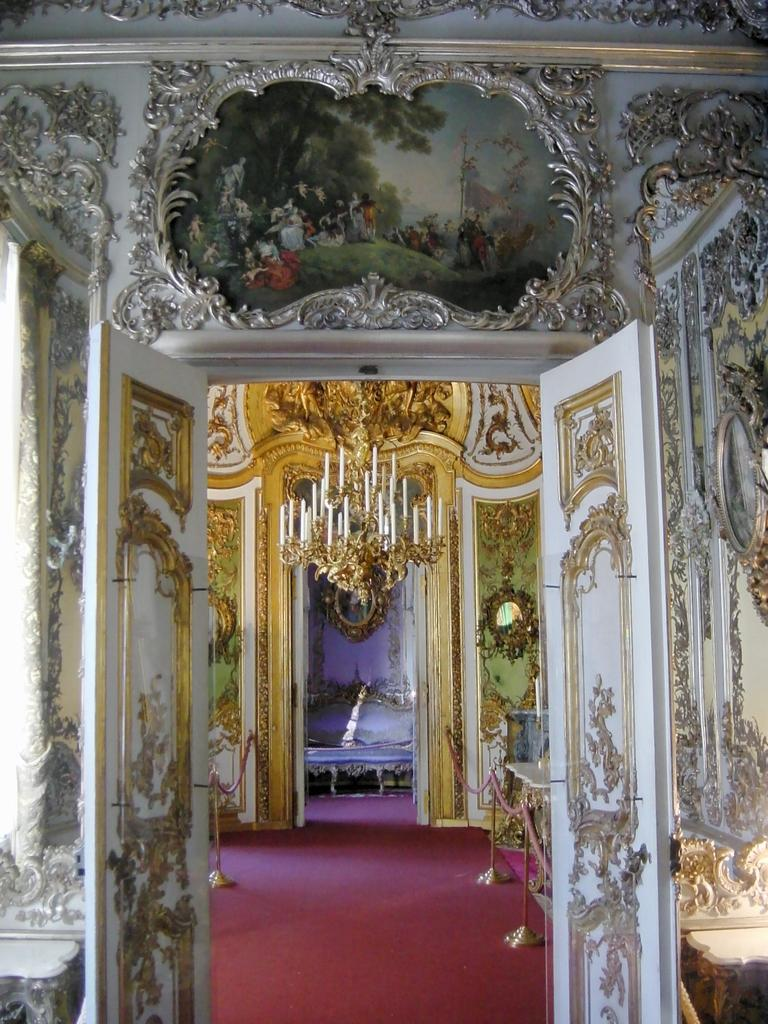What is hanging from the ceiling in the image? There are candles on a chandelier in the image. What can be seen on the doors in the image? The doors in the image are decorated with paintings. What type of floor covering is present in the image? There is a red carpet on the floor in the image. What type of army is depicted in the painting on the door in the image? There is no army depicted in the painting on the door in the image; the painting features decorative designs. Can you tell me how many jellyfish are swimming on the red carpet in the image? There are no jellyfish present in the image; the red carpet is a floor covering. 